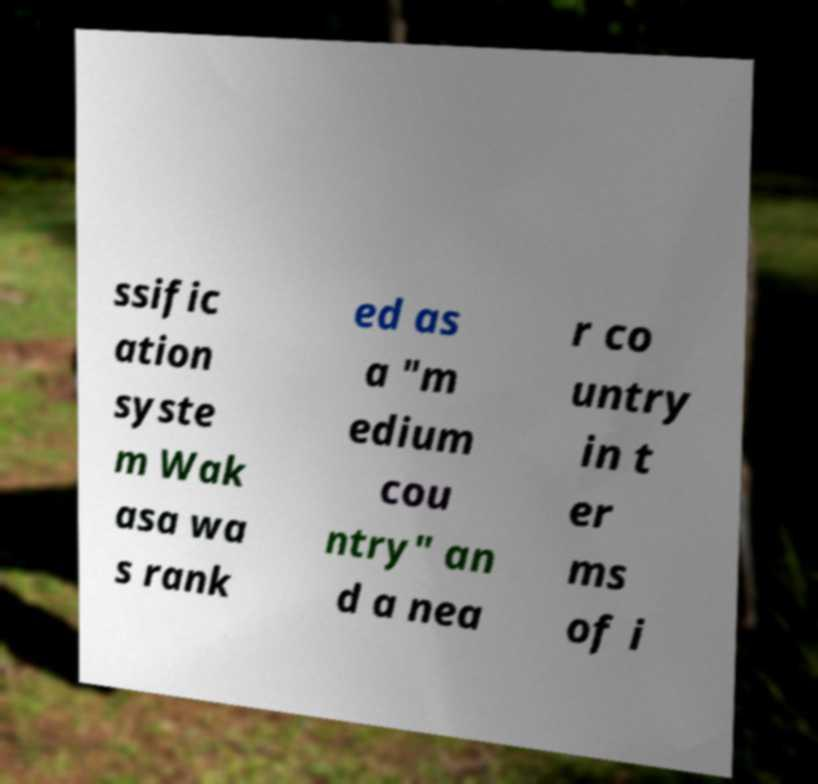There's text embedded in this image that I need extracted. Can you transcribe it verbatim? ssific ation syste m Wak asa wa s rank ed as a "m edium cou ntry" an d a nea r co untry in t er ms of i 